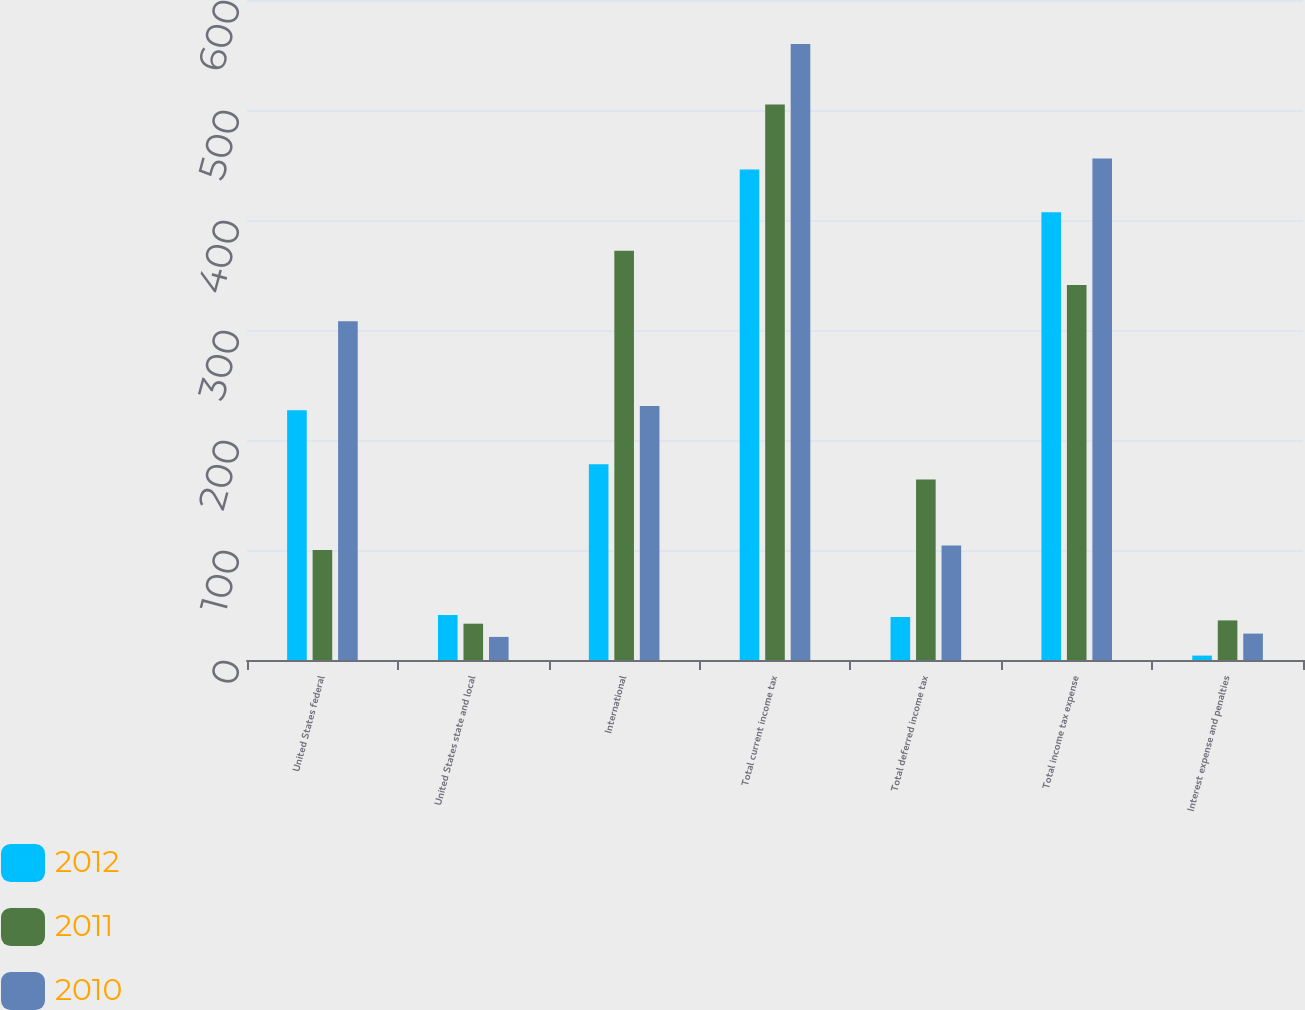Convert chart. <chart><loc_0><loc_0><loc_500><loc_500><stacked_bar_chart><ecel><fcel>United States federal<fcel>United States state and local<fcel>International<fcel>Total current income tax<fcel>Total deferred income tax<fcel>Total income tax expense<fcel>Interest expense and penalties<nl><fcel>2012<fcel>227<fcel>41<fcel>178<fcel>446<fcel>39<fcel>407<fcel>4<nl><fcel>2011<fcel>100<fcel>33<fcel>372<fcel>505<fcel>164<fcel>341<fcel>36<nl><fcel>2010<fcel>308<fcel>21<fcel>231<fcel>560<fcel>104<fcel>456<fcel>24<nl></chart> 